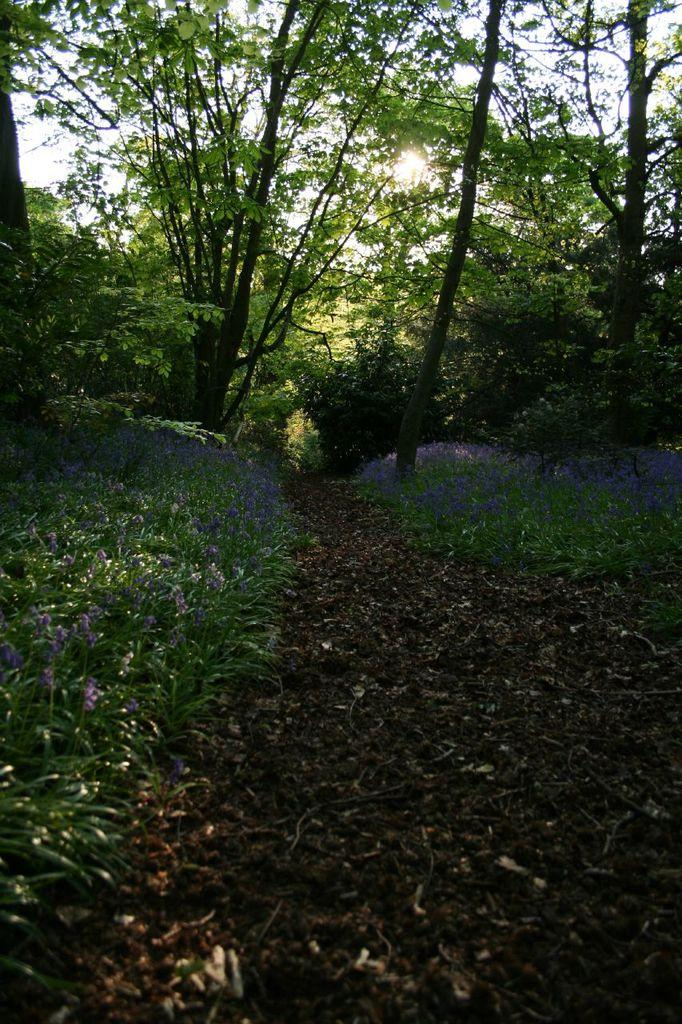What is on the ground in the image? There are dry leaves on the ground in the image. What can be seen on the plants in the image? There are flowers on the plants in the image. What is visible in the background of the image? There are many trees visible in the background of the image. Reasoning: Let' Let's think step by step in order to produce the conversation. We start by identifying the main subjects and objects in the image based on the provided facts. We then formulate questions that focus on the location and characteristics of these subjects and objects, ensuring that each question can be answered definitively with the information given. We avoid yes/no questions and ensure that the language is simple and clear. Absurd Question/Answer: What scent can be detected from the crayon in the image? There is no crayon present in the image, so it is not possible to detect a scent from it. What type of crayon is being used by the aunt in the image? There is no aunt or crayon present in the image, so it is not possible to answer that question. 